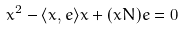<formula> <loc_0><loc_0><loc_500><loc_500>x ^ { 2 } - \langle x , e \rangle x + ( x N ) e = 0</formula> 